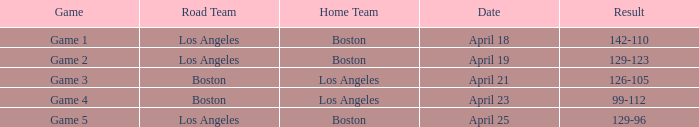WHAT IS THE HOME TEAM, RESULT 99-112? Los Angeles. 